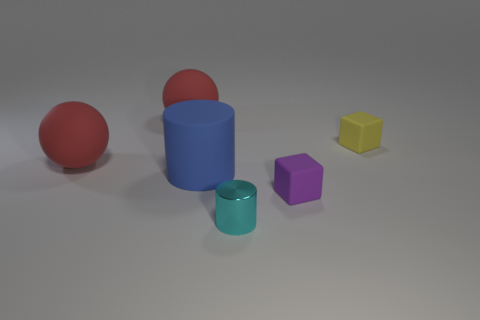Is the number of tiny cyan cylinders that are behind the small cyan metallic cylinder greater than the number of cyan metal objects in front of the yellow matte block?
Your answer should be very brief. No. Is there a big matte sphere?
Give a very brief answer. Yes. What number of things are large red blocks or large blue matte objects?
Offer a terse response. 1. Is there another tiny metal cylinder of the same color as the shiny cylinder?
Make the answer very short. No. There is a large red sphere that is in front of the small yellow rubber block; what number of shiny cylinders are left of it?
Provide a succinct answer. 0. Are there more big blue rubber cylinders than gray metallic things?
Provide a short and direct response. Yes. Are the purple block and the large cylinder made of the same material?
Provide a short and direct response. Yes. Are there an equal number of blue rubber objects in front of the cyan cylinder and small purple objects?
Offer a terse response. No. How many red objects are made of the same material as the purple object?
Keep it short and to the point. 2. Are there fewer tiny cyan shiny cylinders than big red objects?
Offer a very short reply. Yes. 